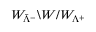Convert formula to latex. <formula><loc_0><loc_0><loc_500><loc_500>W _ { { \bar { \Lambda } } ^ { - } } \ W / W _ { \Lambda ^ { + } }</formula> 